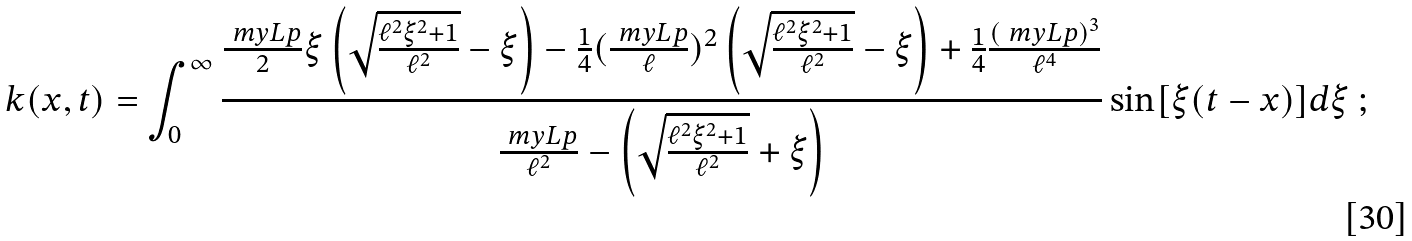Convert formula to latex. <formula><loc_0><loc_0><loc_500><loc_500>k ( x , t ) = \int _ { 0 } ^ { \infty } \frac { \frac { \ m y L p } { 2 } \xi \left ( \sqrt { \frac { \ell ^ { 2 } \xi ^ { 2 } + 1 } { \ell ^ { 2 } } } - \xi \right ) - \frac { 1 } { 4 } ( \frac { \ m y L p } { \ell } ) ^ { 2 } \left ( \sqrt { \frac { \ell ^ { 2 } \xi ^ { 2 } + 1 } { \ell ^ { 2 } } } - \xi \right ) + \frac { 1 } { 4 } \frac { ( \ m y L p ) ^ { 3 } } { \ell ^ { 4 } } } { \frac { \ m y L p } { \ell ^ { 2 } } - \left ( \sqrt { \frac { \ell ^ { 2 } \xi ^ { 2 } + 1 } { \ell ^ { 2 } } } + \xi \right ) } \sin [ \xi ( t - x ) ] d \xi \ ;</formula> 